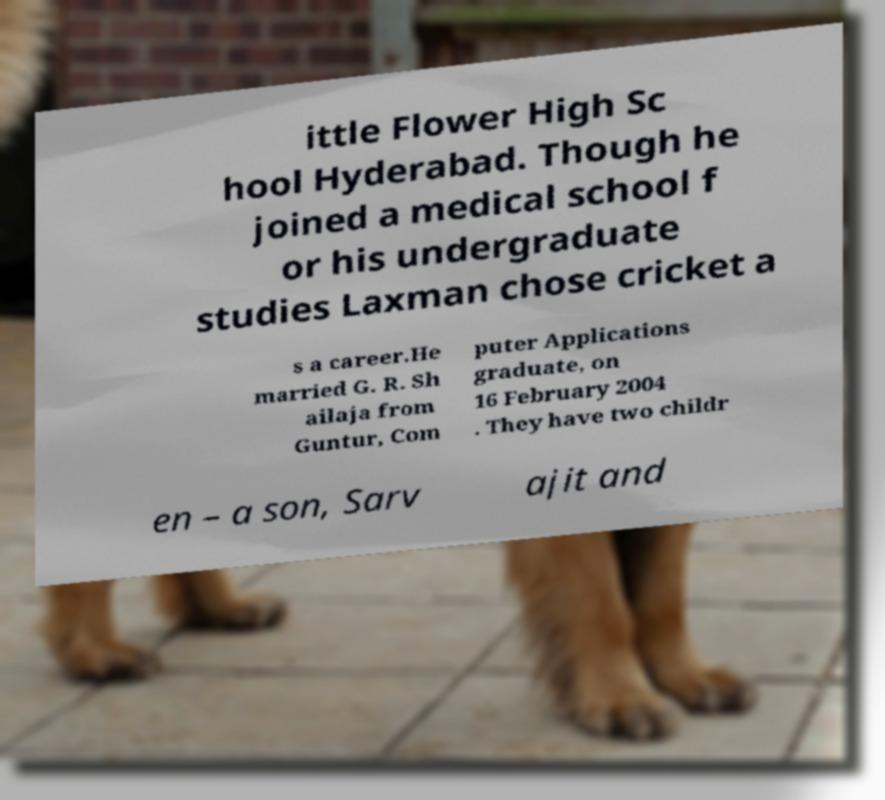Please identify and transcribe the text found in this image. ittle Flower High Sc hool Hyderabad. Though he joined a medical school f or his undergraduate studies Laxman chose cricket a s a career.He married G. R. Sh ailaja from Guntur, Com puter Applications graduate, on 16 February 2004 . They have two childr en – a son, Sarv ajit and 